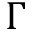<formula> <loc_0><loc_0><loc_500><loc_500>\Gamma</formula> 